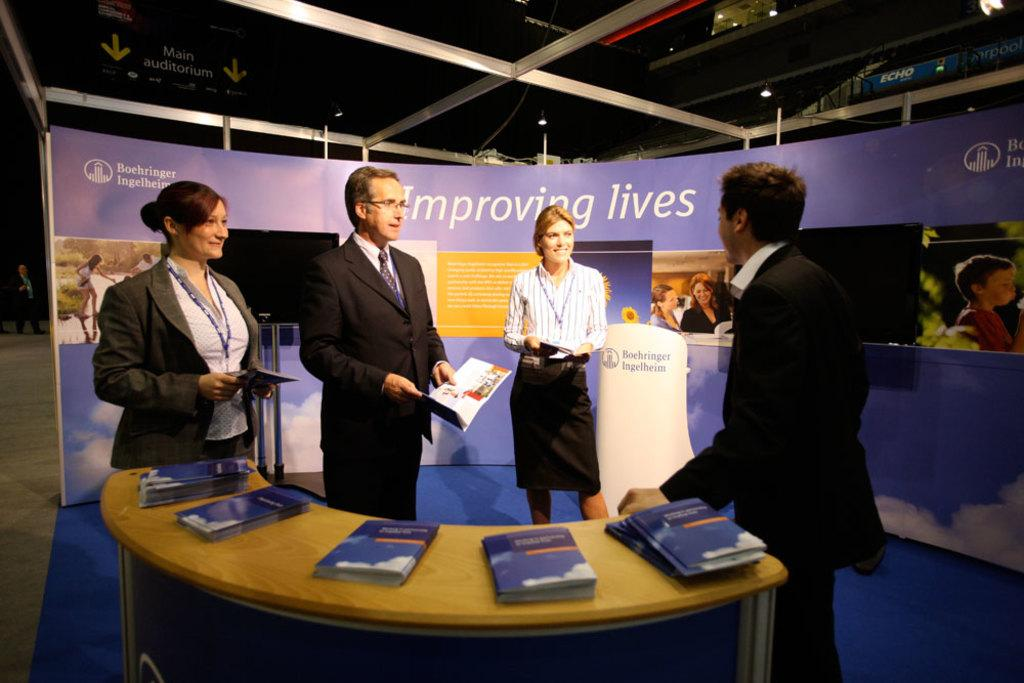How many men and women are present in the image? There are two men and two women in the image. What are the people in the image doing? The people are standing and holding books. What can be seen on the table in the image? There is a table with books on it in the image. What is visible in the background of the image? There is a banner in the background of the image. What type of oven can be seen in the image? There is no oven present in the image. What time of day is it in the image, given the presence of the line? There is no line present in the image, and the time of day cannot be determined from the image alone. 